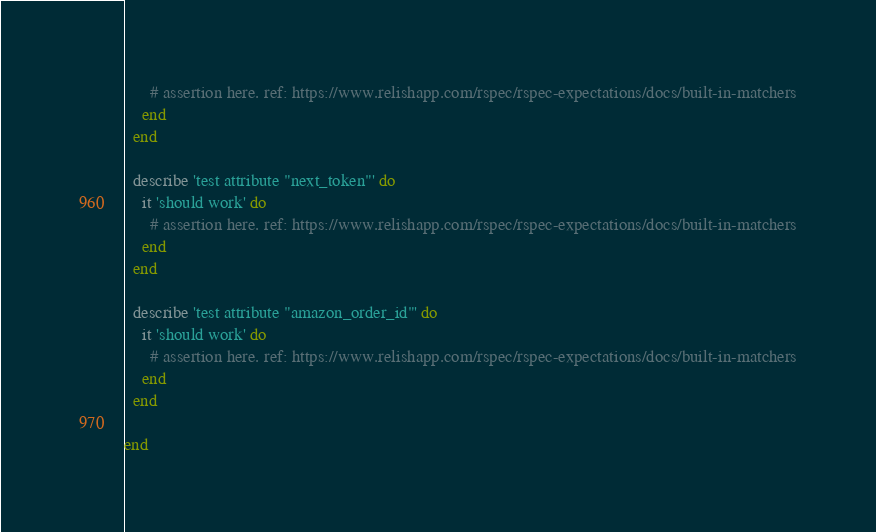<code> <loc_0><loc_0><loc_500><loc_500><_Ruby_>      # assertion here. ref: https://www.relishapp.com/rspec/rspec-expectations/docs/built-in-matchers
    end
  end

  describe 'test attribute "next_token"' do
    it 'should work' do
      # assertion here. ref: https://www.relishapp.com/rspec/rspec-expectations/docs/built-in-matchers
    end
  end

  describe 'test attribute "amazon_order_id"' do
    it 'should work' do
      # assertion here. ref: https://www.relishapp.com/rspec/rspec-expectations/docs/built-in-matchers
    end
  end

end
</code> 